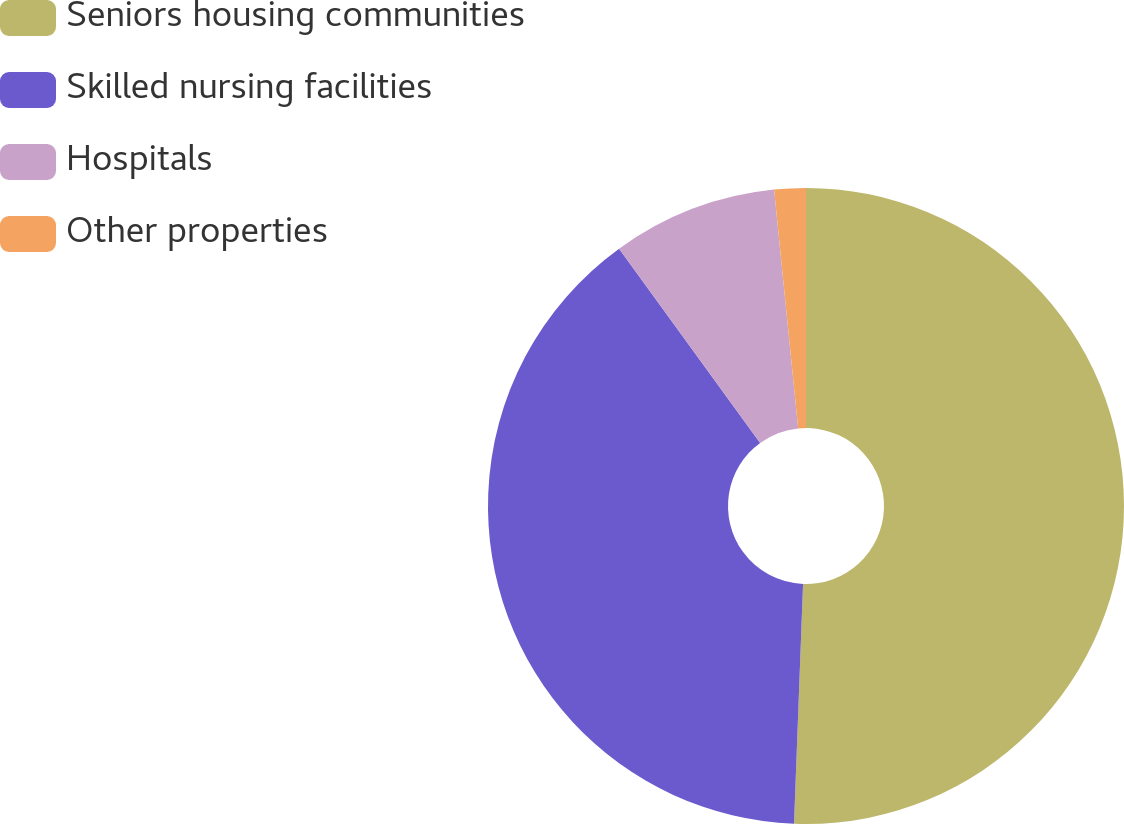<chart> <loc_0><loc_0><loc_500><loc_500><pie_chart><fcel>Seniors housing communities<fcel>Skilled nursing facilities<fcel>Hospitals<fcel>Other properties<nl><fcel>50.6%<fcel>39.4%<fcel>8.4%<fcel>1.6%<nl></chart> 